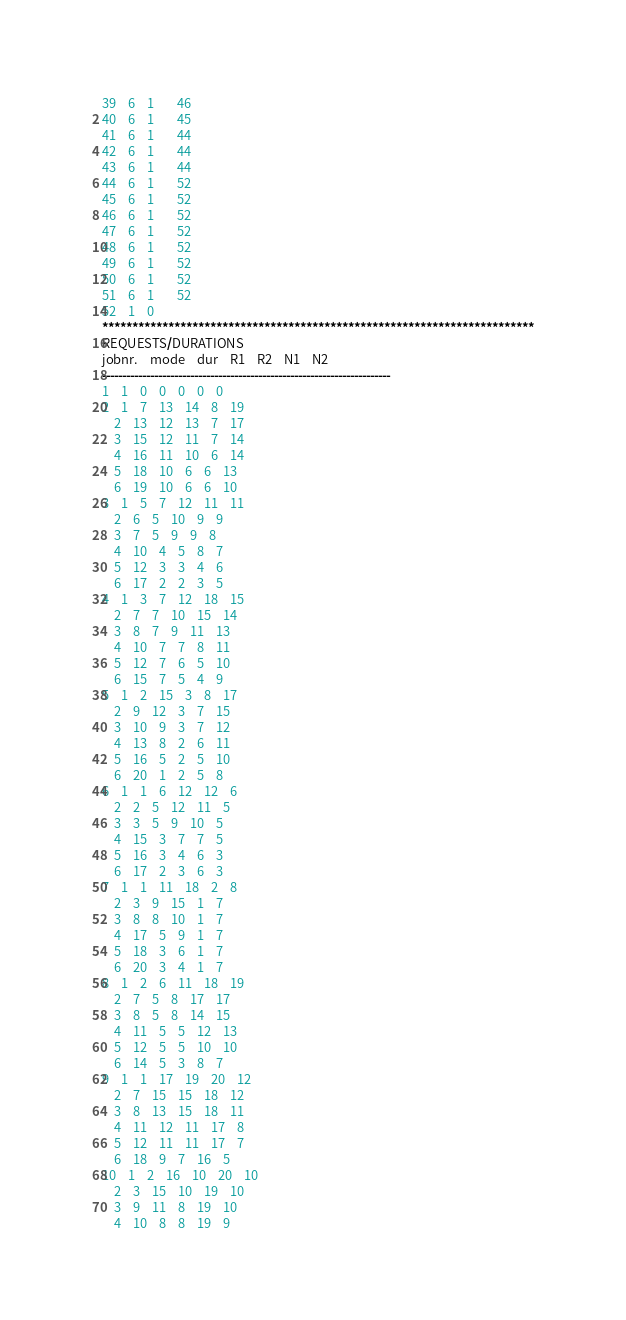Convert code to text. <code><loc_0><loc_0><loc_500><loc_500><_ObjectiveC_>39	6	1		46 
40	6	1		45 
41	6	1		44 
42	6	1		44 
43	6	1		44 
44	6	1		52 
45	6	1		52 
46	6	1		52 
47	6	1		52 
48	6	1		52 
49	6	1		52 
50	6	1		52 
51	6	1		52 
52	1	0		
************************************************************************
REQUESTS/DURATIONS
jobnr.	mode	dur	R1	R2	N1	N2	
------------------------------------------------------------------------
1	1	0	0	0	0	0	
2	1	7	13	14	8	19	
	2	13	12	13	7	17	
	3	15	12	11	7	14	
	4	16	11	10	6	14	
	5	18	10	6	6	13	
	6	19	10	6	6	10	
3	1	5	7	12	11	11	
	2	6	5	10	9	9	
	3	7	5	9	9	8	
	4	10	4	5	8	7	
	5	12	3	3	4	6	
	6	17	2	2	3	5	
4	1	3	7	12	18	15	
	2	7	7	10	15	14	
	3	8	7	9	11	13	
	4	10	7	7	8	11	
	5	12	7	6	5	10	
	6	15	7	5	4	9	
5	1	2	15	3	8	17	
	2	9	12	3	7	15	
	3	10	9	3	7	12	
	4	13	8	2	6	11	
	5	16	5	2	5	10	
	6	20	1	2	5	8	
6	1	1	6	12	12	6	
	2	2	5	12	11	5	
	3	3	5	9	10	5	
	4	15	3	7	7	5	
	5	16	3	4	6	3	
	6	17	2	3	6	3	
7	1	1	11	18	2	8	
	2	3	9	15	1	7	
	3	8	8	10	1	7	
	4	17	5	9	1	7	
	5	18	3	6	1	7	
	6	20	3	4	1	7	
8	1	2	6	11	18	19	
	2	7	5	8	17	17	
	3	8	5	8	14	15	
	4	11	5	5	12	13	
	5	12	5	5	10	10	
	6	14	5	3	8	7	
9	1	1	17	19	20	12	
	2	7	15	15	18	12	
	3	8	13	15	18	11	
	4	11	12	11	17	8	
	5	12	11	11	17	7	
	6	18	9	7	16	5	
10	1	2	16	10	20	10	
	2	3	15	10	19	10	
	3	9	11	8	19	10	
	4	10	8	8	19	9	</code> 